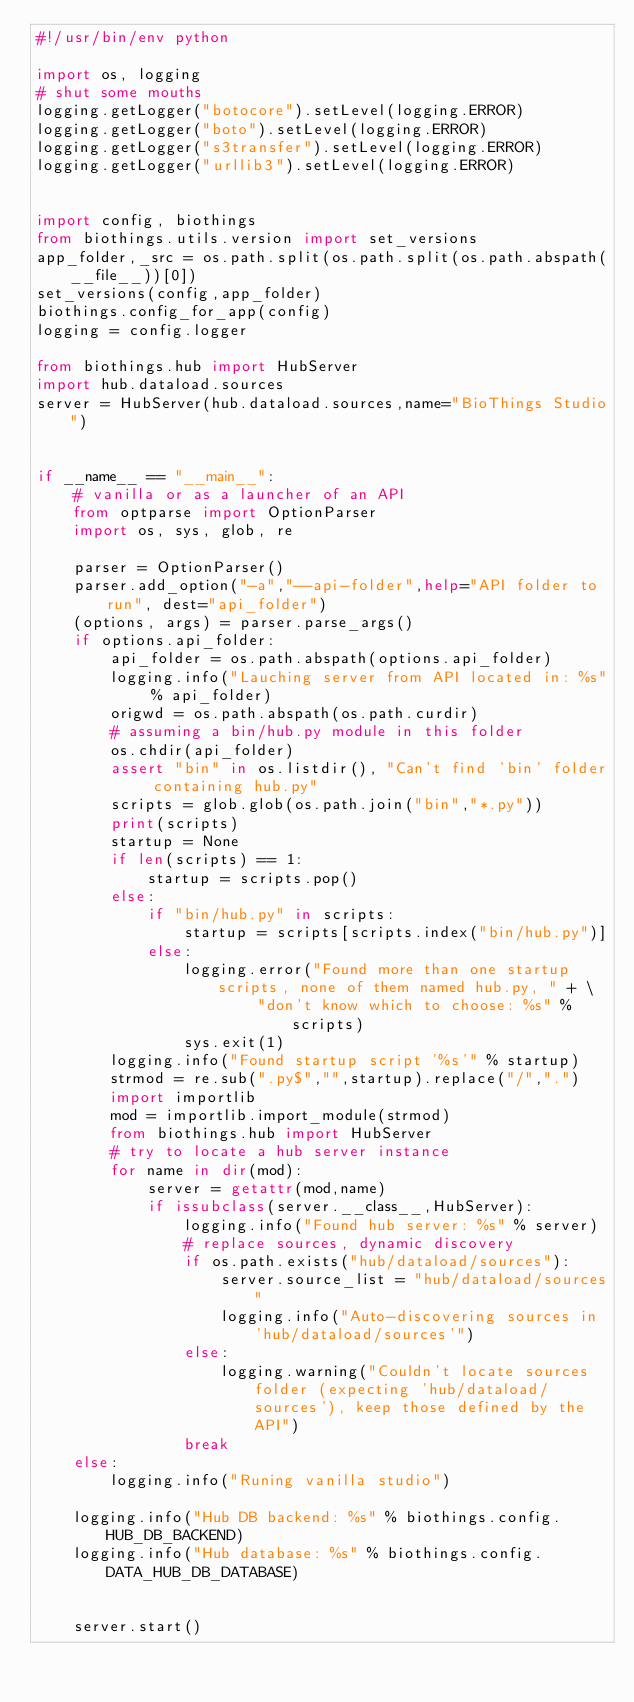<code> <loc_0><loc_0><loc_500><loc_500><_Python_>#!/usr/bin/env python

import os, logging
# shut some mouths
logging.getLogger("botocore").setLevel(logging.ERROR)
logging.getLogger("boto").setLevel(logging.ERROR)
logging.getLogger("s3transfer").setLevel(logging.ERROR)
logging.getLogger("urllib3").setLevel(logging.ERROR)


import config, biothings
from biothings.utils.version import set_versions
app_folder,_src = os.path.split(os.path.split(os.path.abspath(__file__))[0])
set_versions(config,app_folder)
biothings.config_for_app(config)
logging = config.logger

from biothings.hub import HubServer
import hub.dataload.sources
server = HubServer(hub.dataload.sources,name="BioThings Studio")


if __name__ == "__main__":
    # vanilla or as a launcher of an API
    from optparse import OptionParser
    import os, sys, glob, re

    parser = OptionParser()
    parser.add_option("-a","--api-folder",help="API folder to run", dest="api_folder")
    (options, args) = parser.parse_args()
    if options.api_folder:
        api_folder = os.path.abspath(options.api_folder)
        logging.info("Lauching server from API located in: %s" % api_folder)
        origwd = os.path.abspath(os.path.curdir)
        # assuming a bin/hub.py module in this folder
        os.chdir(api_folder)
        assert "bin" in os.listdir(), "Can't find 'bin' folder containing hub.py"
        scripts = glob.glob(os.path.join("bin","*.py"))
        print(scripts)
        startup = None
        if len(scripts) == 1:
            startup = scripts.pop()
        else:
            if "bin/hub.py" in scripts:
                startup = scripts[scripts.index("bin/hub.py")]
            else:
                logging.error("Found more than one startup scripts, none of them named hub.py, " + \
                        "don't know which to choose: %s" % scripts)
                sys.exit(1)
        logging.info("Found startup script '%s'" % startup)
        strmod = re.sub(".py$","",startup).replace("/",".")
        import importlib
        mod = importlib.import_module(strmod)
        from biothings.hub import HubServer
        # try to locate a hub server instance
        for name in dir(mod):
            server = getattr(mod,name)
            if issubclass(server.__class__,HubServer):
                logging.info("Found hub server: %s" % server)
                # replace sources, dynamic discovery
                if os.path.exists("hub/dataload/sources"):
                    server.source_list = "hub/dataload/sources"
                    logging.info("Auto-discovering sources in 'hub/dataload/sources'")
                else:
                    logging.warning("Couldn't locate sources folder (expecting 'hub/dataload/sources'), keep those defined by the API")
                break
    else:
        logging.info("Runing vanilla studio")

    logging.info("Hub DB backend: %s" % biothings.config.HUB_DB_BACKEND)
    logging.info("Hub database: %s" % biothings.config.DATA_HUB_DB_DATABASE)


    server.start()
</code> 